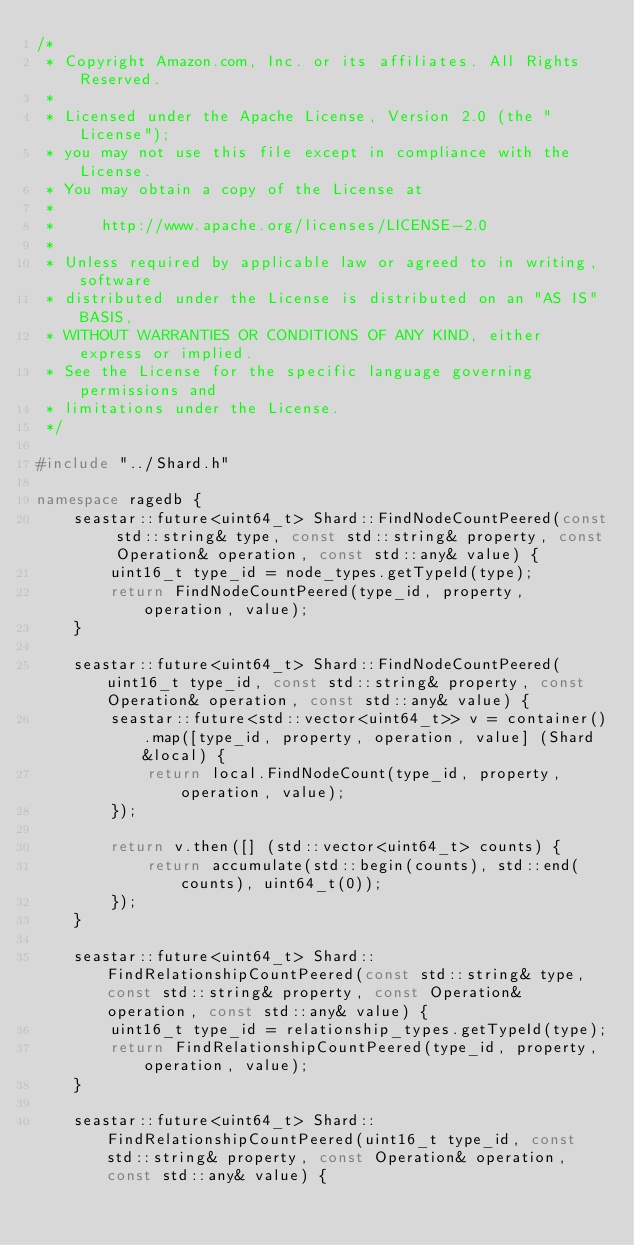Convert code to text. <code><loc_0><loc_0><loc_500><loc_500><_C++_>/*
 * Copyright Amazon.com, Inc. or its affiliates. All Rights Reserved.
 *
 * Licensed under the Apache License, Version 2.0 (the "License");
 * you may not use this file except in compliance with the License.
 * You may obtain a copy of the License at
 *
 *     http://www.apache.org/licenses/LICENSE-2.0
 *
 * Unless required by applicable law or agreed to in writing, software
 * distributed under the License is distributed on an "AS IS" BASIS,
 * WITHOUT WARRANTIES OR CONDITIONS OF ANY KIND, either express or implied.
 * See the License for the specific language governing permissions and
 * limitations under the License.
 */

#include "../Shard.h"

namespace ragedb {
    seastar::future<uint64_t> Shard::FindNodeCountPeered(const std::string& type, const std::string& property, const Operation& operation, const std::any& value) {
        uint16_t type_id = node_types.getTypeId(type);
        return FindNodeCountPeered(type_id, property, operation, value);
    }

    seastar::future<uint64_t> Shard::FindNodeCountPeered(uint16_t type_id, const std::string& property, const Operation& operation, const std::any& value) {
        seastar::future<std::vector<uint64_t>> v = container().map([type_id, property, operation, value] (Shard &local) {
            return local.FindNodeCount(type_id, property, operation, value);
        });

        return v.then([] (std::vector<uint64_t> counts) {
            return accumulate(std::begin(counts), std::end(counts), uint64_t(0));
        });
    }

    seastar::future<uint64_t> Shard::FindRelationshipCountPeered(const std::string& type, const std::string& property, const Operation& operation, const std::any& value) {
        uint16_t type_id = relationship_types.getTypeId(type);
        return FindRelationshipCountPeered(type_id, property, operation, value);
    }

    seastar::future<uint64_t> Shard::FindRelationshipCountPeered(uint16_t type_id, const std::string& property, const Operation& operation, const std::any& value) {</code> 